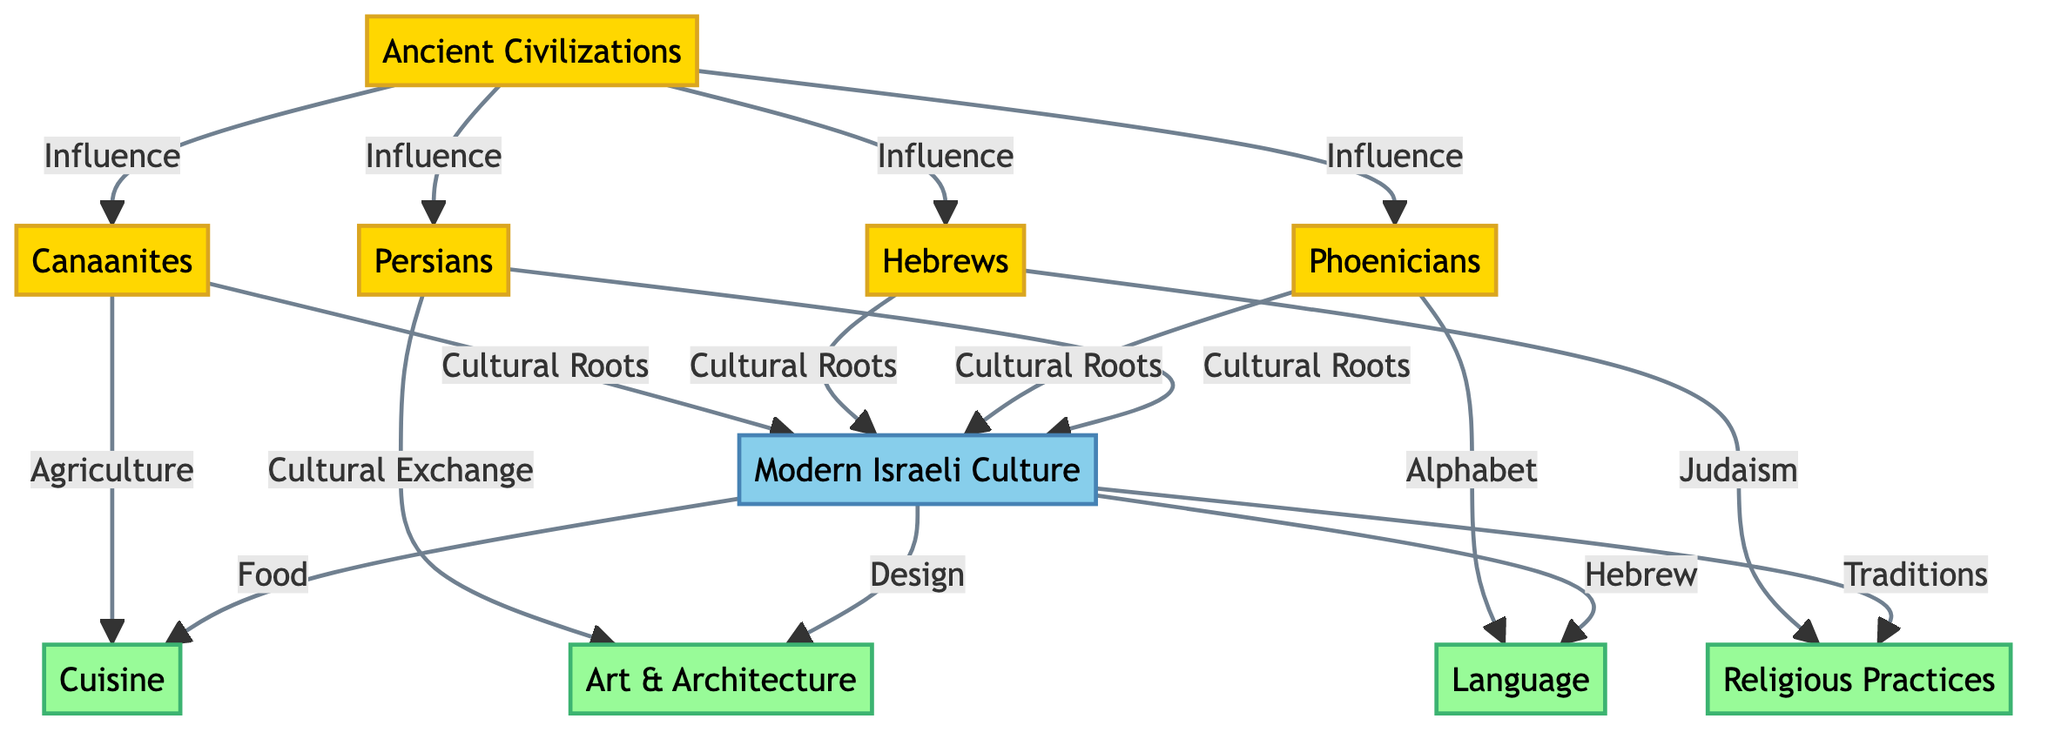What are the four ancient civilizations listed in the diagram? The diagram shows four nodes under the "Ancient Civilizations" category: Canaanites, Hebrews, Phoenicians, and Persians.
Answer: Canaanites, Hebrews, Phoenicians, Persians What modern aspect is influenced by Agriculture? The diagram indicates that agriculture, represented by the Canaanites, influences modern cuisine as shown by the direct connection in the flowchart.
Answer: Cuisine How many ancient civilizations are shown in the diagram? There are four ancient civilizations connected to modern Israeli culture, specifically those that influence it.
Answer: 4 What aspect of modern Israeli culture is associated with Judaism? The diagram specifically connects the Hebrews, who are associated with Judaism, to modern religious practices.
Answer: Religious Practices Which ancient civilization contributed to the development of the alphabet? The flowchart connects the Phoenicians to the modern aspect of language, indicating their contribution to the development of the alphabet.
Answer: Phoenicians What is the main cultural root of modern Israeli culture? The diagram shows that ancient civilizations provide cultural roots for modern Israeli culture, with direct connections leading from them to it.
Answer: Cultural Roots Which modern aspect is linked to the influence of Persians? According to the diagram, the Persians contribute to modern art and architecture through the mechanism of cultural exchange.
Answer: Art & Architecture How does modern Israeli culture relate to Hebrew? The diagram illustrates a direct connection between modern Israeli culture and Hebrew language as an influence from ancient civilizations.
Answer: Hebrew What type of diagram is represented here? The structure and content of the diagram reveal that it is a social science diagram focusing on the influence of ancient civilizations on modern cultural practices.
Answer: Social Science Diagram 